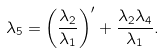Convert formula to latex. <formula><loc_0><loc_0><loc_500><loc_500>\lambda _ { 5 } = \left ( \frac { \lambda _ { 2 } } { \lambda _ { 1 } } \right ) ^ { \prime } + \frac { \lambda _ { 2 } \lambda _ { 4 } } { \lambda _ { 1 } } .</formula> 